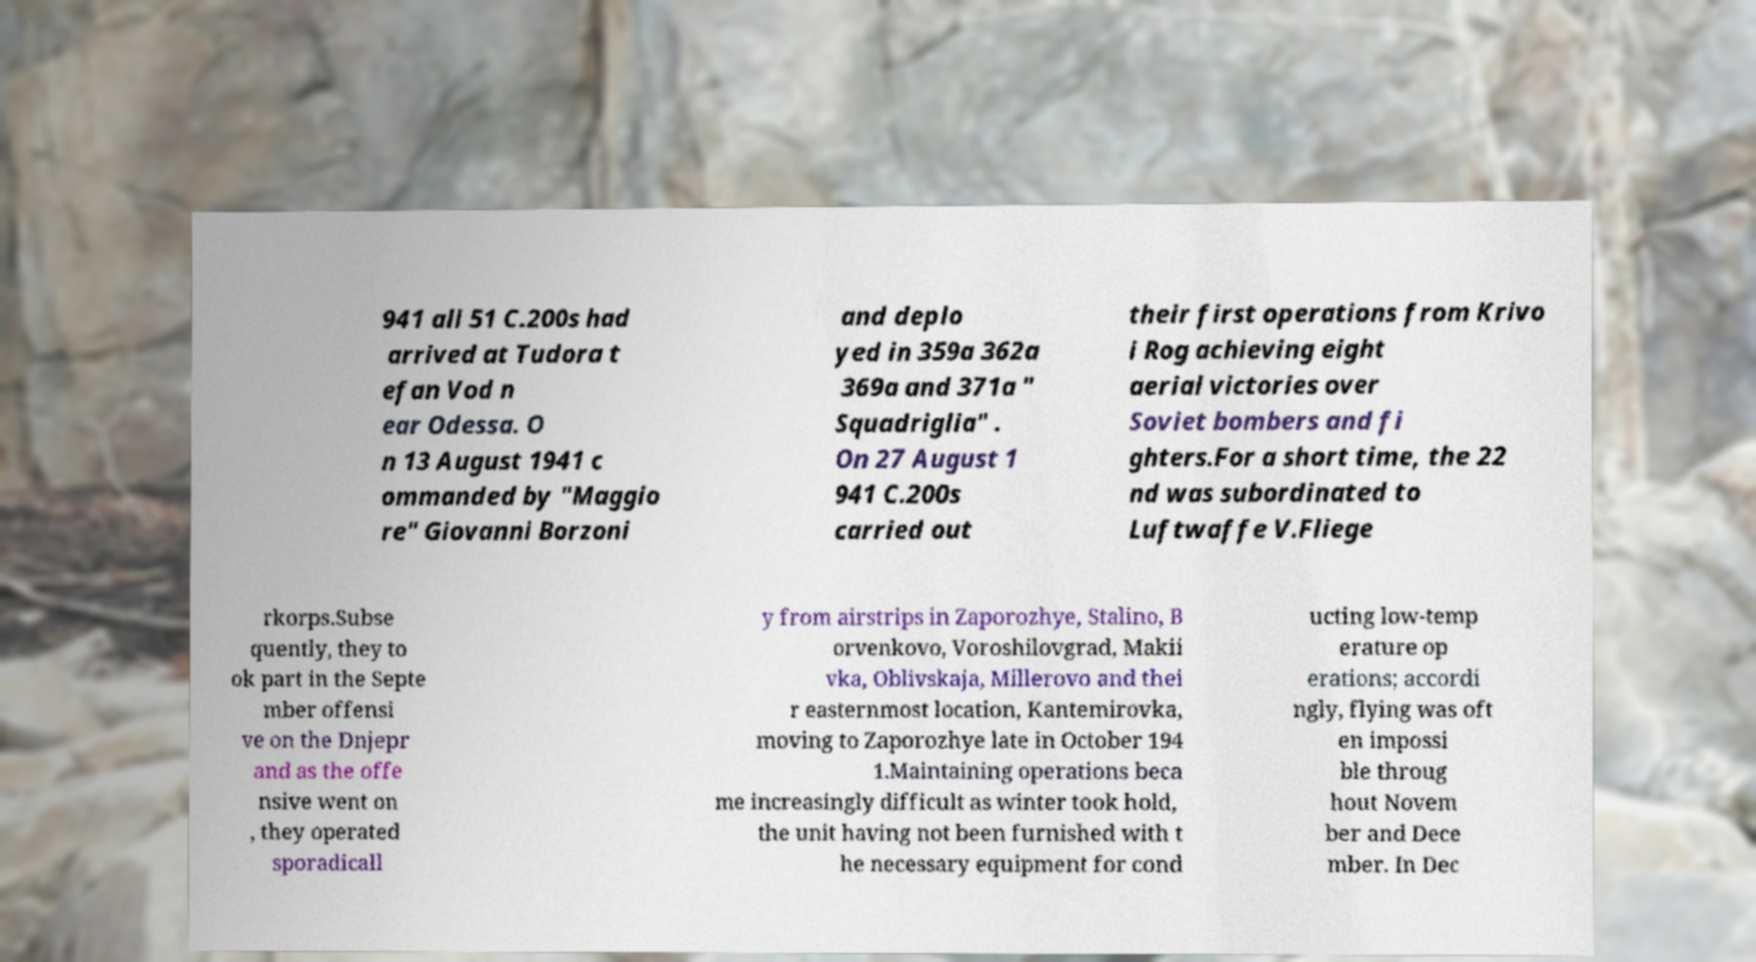For documentation purposes, I need the text within this image transcribed. Could you provide that? 941 all 51 C.200s had arrived at Tudora t efan Vod n ear Odessa. O n 13 August 1941 c ommanded by "Maggio re" Giovanni Borzoni and deplo yed in 359a 362a 369a and 371a " Squadriglia" . On 27 August 1 941 C.200s carried out their first operations from Krivo i Rog achieving eight aerial victories over Soviet bombers and fi ghters.For a short time, the 22 nd was subordinated to Luftwaffe V.Fliege rkorps.Subse quently, they to ok part in the Septe mber offensi ve on the Dnjepr and as the offe nsive went on , they operated sporadicall y from airstrips in Zaporozhye, Stalino, B orvenkovo, Voroshilovgrad, Makii vka, Oblivskaja, Millerovo and thei r easternmost location, Kantemirovka, moving to Zaporozhye late in October 194 1.Maintaining operations beca me increasingly difficult as winter took hold, the unit having not been furnished with t he necessary equipment for cond ucting low-temp erature op erations; accordi ngly, flying was oft en impossi ble throug hout Novem ber and Dece mber. In Dec 